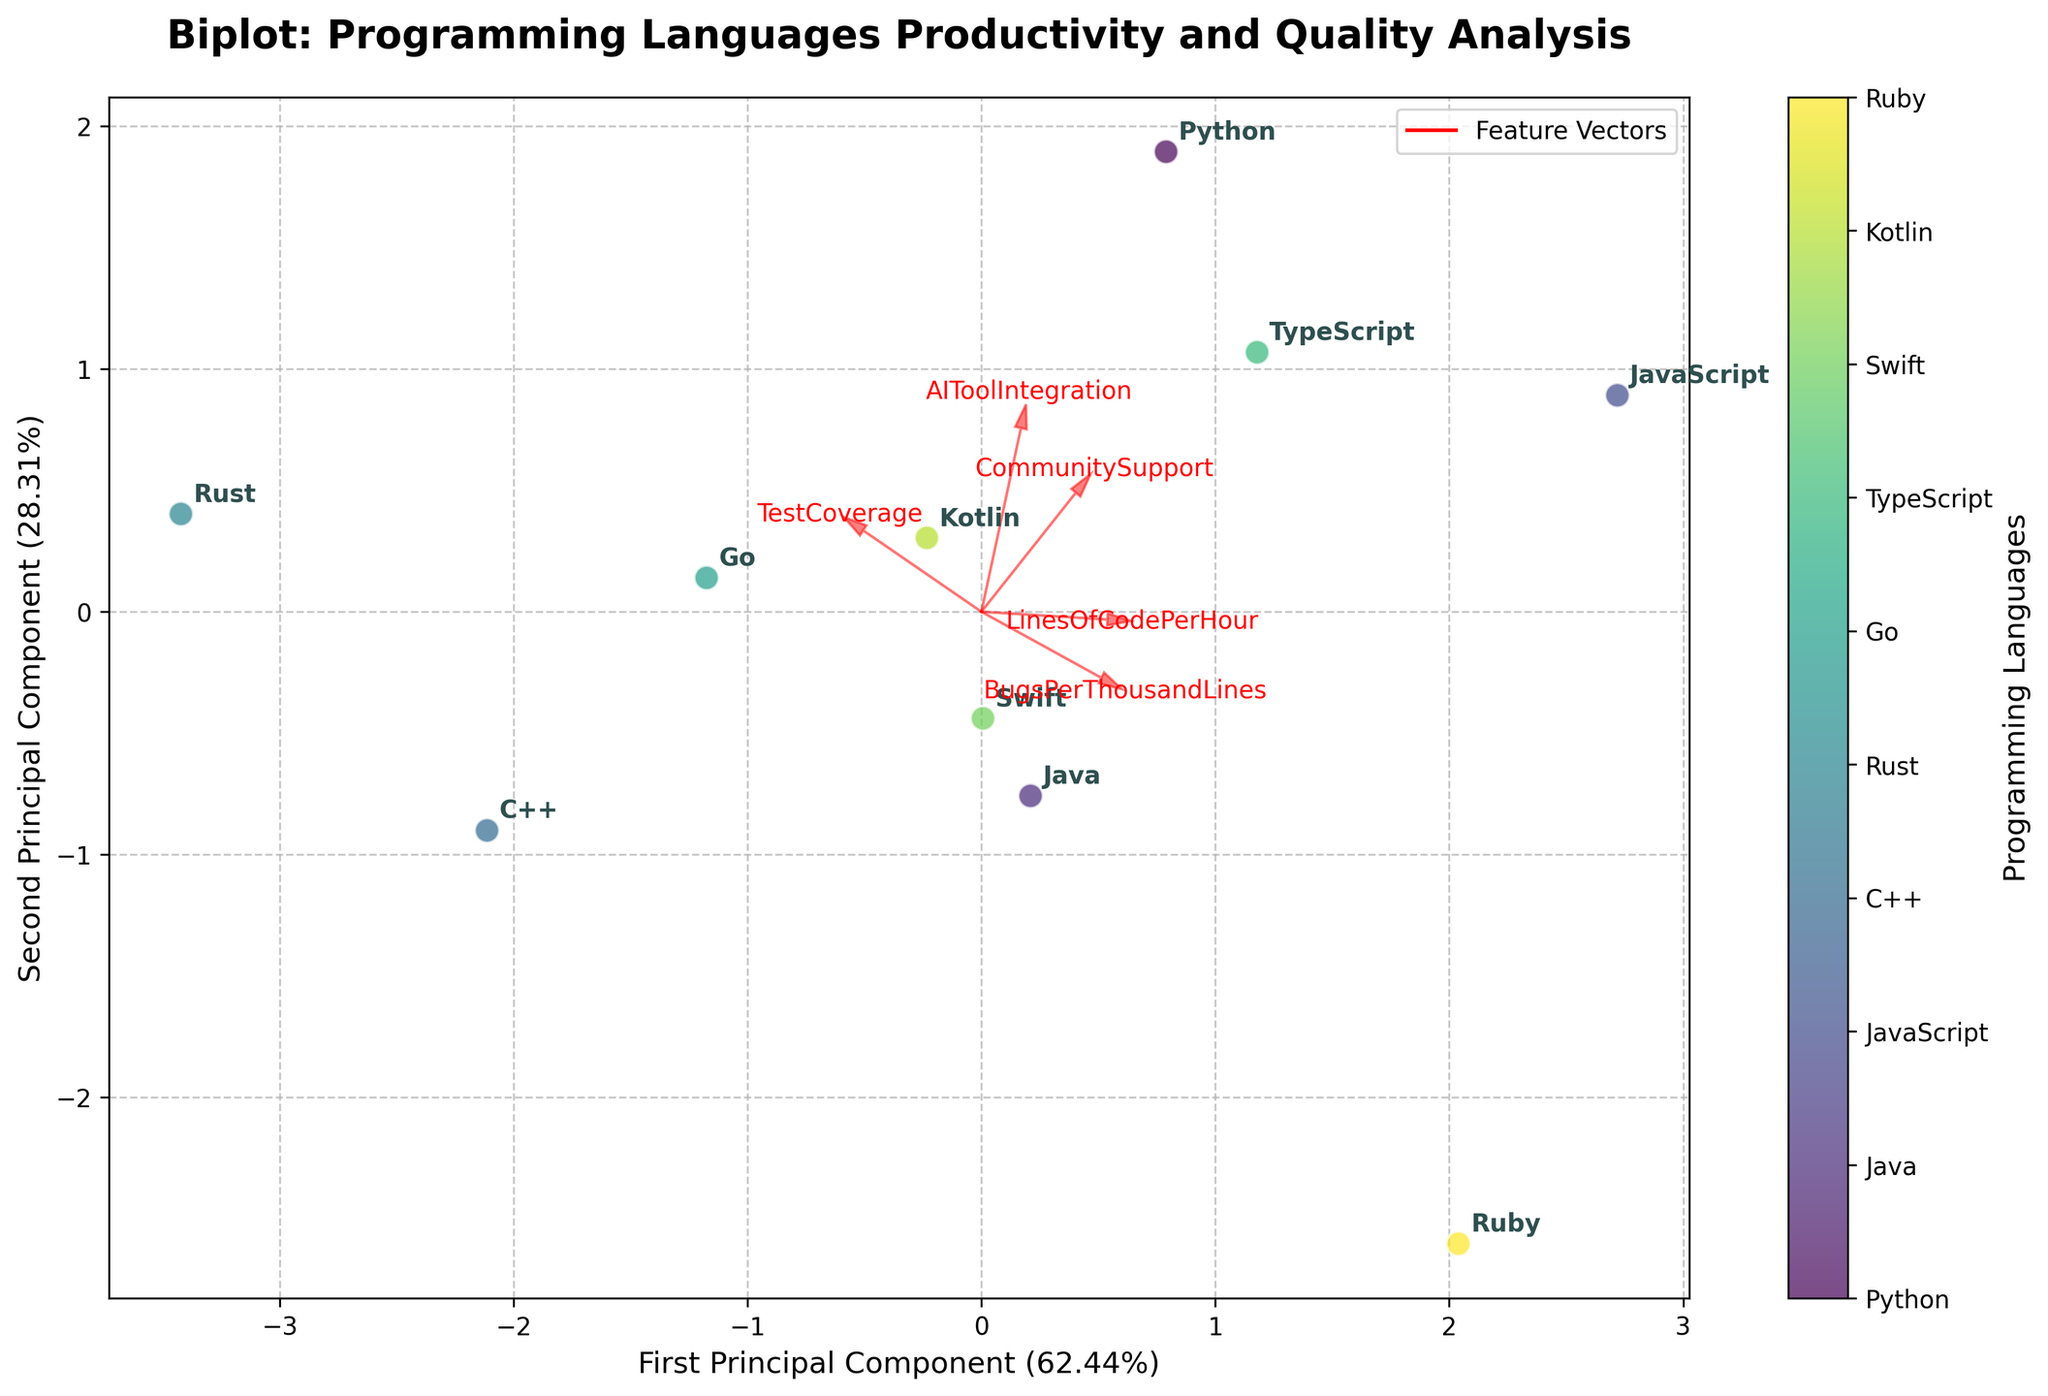How many programming languages are represented in the plot? Count the total number of unique labels annotated.
Answer: 10 Which programming language has the lowest 'LinesOfCodePerHour'? Identify the language closest to the origin based on the 'LinesOfCodePerHour' vector direction and coordinates.
Answer: Rust What is the first principal component's explained variance ratio displayed on the X-axis? Read the percentage value given on the X-axis label.
Answer: 48% Between Python and Ruby, which one has higher 'TestCoverage'? Check the relative positions concerning the 'TestCoverage' feature vector direction for Python and Ruby.
Answer: Python Compare the positions of C++ and JavaScript on the plot. Which has more 'CommunitySupport'? Observe the alignment of C++ and JavaScript concerning the 'CommunitySupport' feature vector direction.
Answer: JavaScript Which two features have nearly opposite directions? Look at the angles formed between the feature vectors to determine which ones are nearly 180 degrees apart.
Answer: 'LinesOfCodePerHour' and 'BugsPerThousandLines' By how much more does Python have 'AIToolIntegration' compared to C++? Compare the positions of Python and C++ along the 'AIToolIntegration' vector and estimate the difference.
Answer: 4 units Which programming language demonstrates a balanced performance in both code productivity and quality, based on their Principal Component scores? Look for a language close to the center of the plot, indicating balanced scores in both principal components.
Answer: Go Among the programming languages, which one has the highest 'BugsPerThousandLines'? Assess which data point aligns furthest in the direction of the 'BugsPerThousandLines' vector.
Answer: Ruby What is the general trend between 'LinesOfCodePerHour' and 'TestCoverage' based on the feature vectors? Examine the angles and directions of the 'LinesOfCodePerHour' and 'TestCoverage' vectors relative to each other.
Answer: Positive correlation 